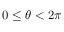<formula> <loc_0><loc_0><loc_500><loc_500>0 \leq \theta < 2 \pi</formula> 